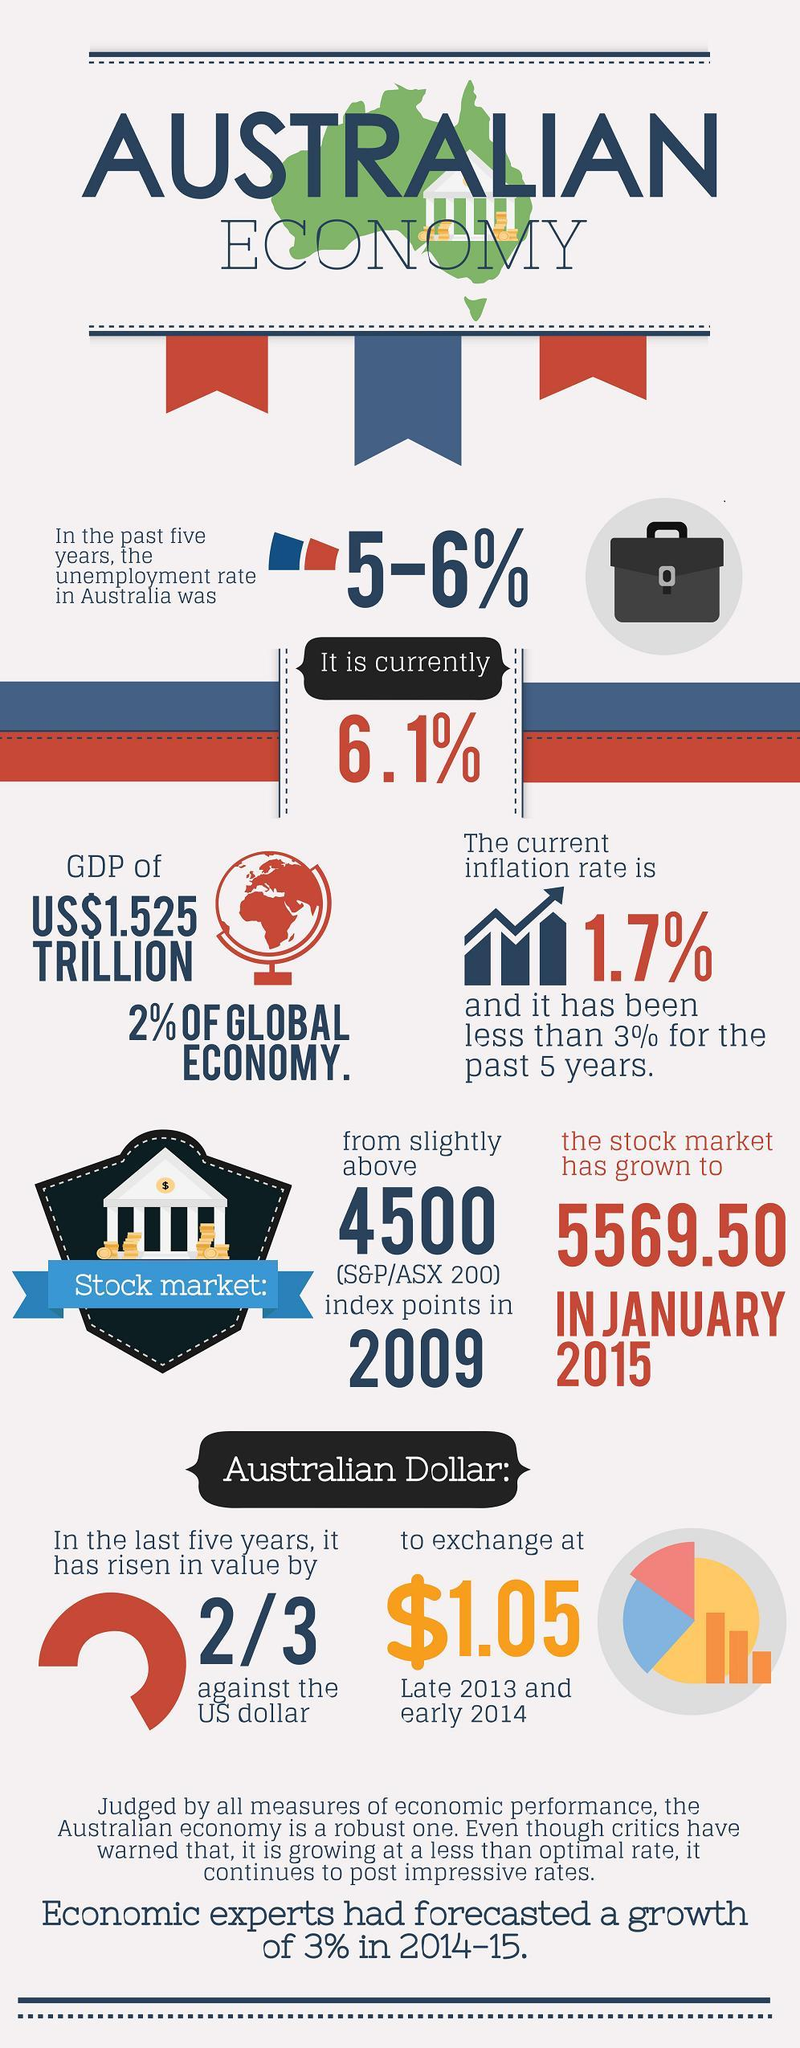What is the s&p/asx 200 index of australian stock market in January 2015?
Answer the question with a short phrase. 5569.50 What is the current inflation rate in australia? 1.7% 